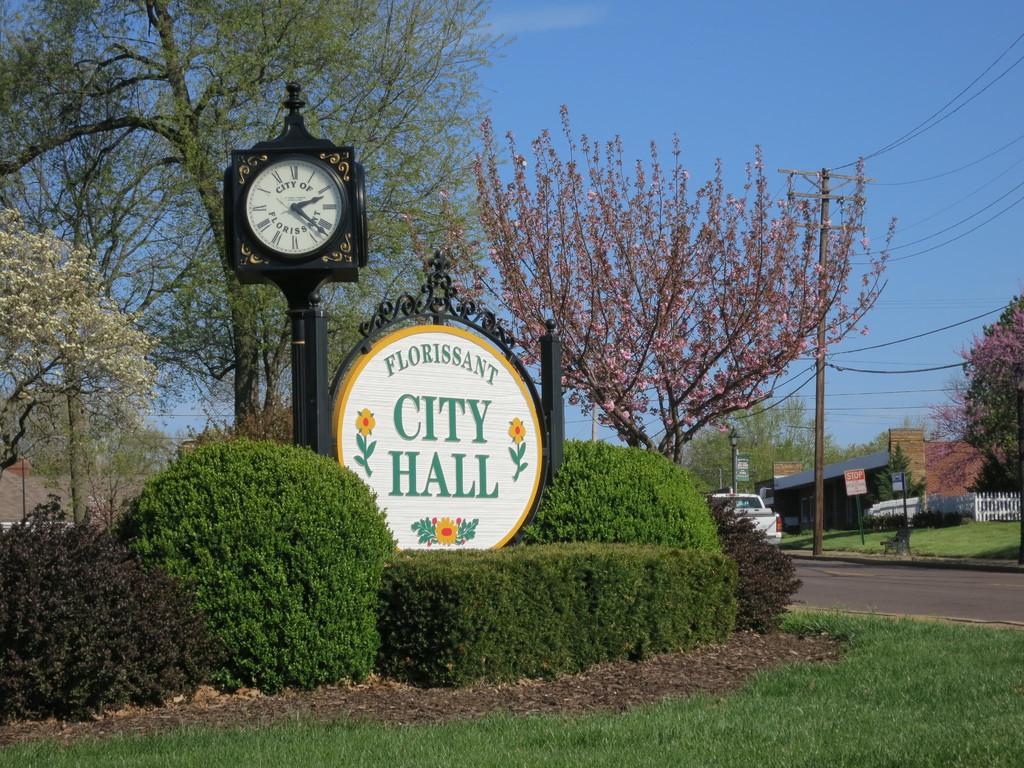What time is on the clock?
Offer a terse response. 2:22. 